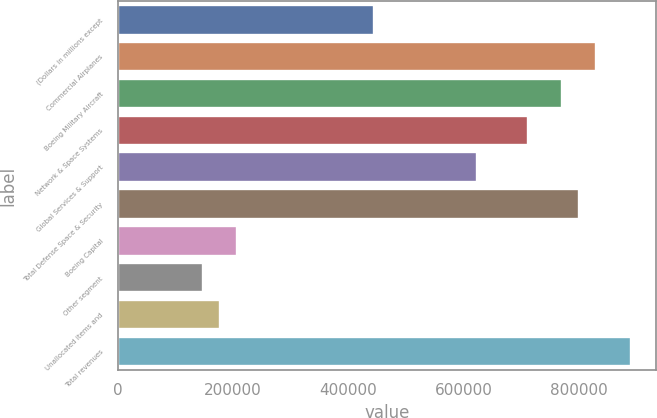Convert chart. <chart><loc_0><loc_0><loc_500><loc_500><bar_chart><fcel>(Dollars in millions except<fcel>Commercial Airplanes<fcel>Boeing Military Aircraft<fcel>Network & Space Systems<fcel>Global Services & Support<fcel>Total Defense Space & Security<fcel>Boeing Capital<fcel>Other segment<fcel>Unallocated items and<fcel>Total revenues<nl><fcel>444749<fcel>830197<fcel>770897<fcel>711598<fcel>622648<fcel>800547<fcel>207550<fcel>148251<fcel>177901<fcel>889497<nl></chart> 